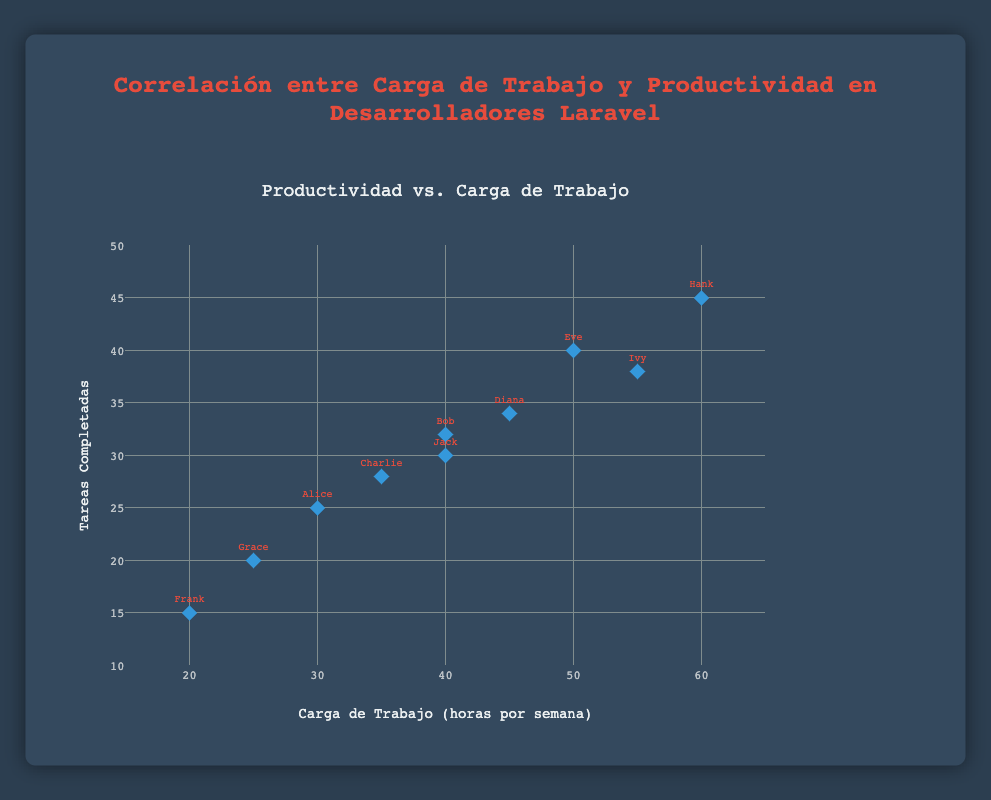How many developers are represented in the scatter plot? There are ten data points, each corresponding to a different developer. The plot visualizes each developer’s workload and productivity.
Answer: 10 Which developer completed the most tasks? By examining the y-axis and the data points, Hank has the highest y-value at 45 completed tasks.
Answer: Hank What is the workload and productivity of Alice? The scatter plot positions Alice's data point at 30 hours per week on the x-axis and 25 completed tasks on the y-axis.
Answer: 30 hours per week, 25 completed tasks Who works 40 hours per week, and how many tasks do they complete? The data points for Bob and Jack both align with 40 hours per week on the x-axis. Bob completes 32 tasks, and Jack completes 30 tasks.
Answer: Bob (32 tasks), Jack (30 tasks) Compare the productivity between Grace and Diana. Who is more productive, and by how much? Grace's productivity is at 20 tasks, while Diana's is at 34 tasks. The difference is 34 - 20 = 14.
Answer: Diana is more productive by 14 tasks What is the average number of tasks completed by developers working more than 40 hours per week? Developers working more than 40 hours are Diana (34 tasks), Eve (40 tasks), Ivy (38 tasks), and Hank (45 tasks). The average is calculated as (34 + 40 + 38 + 45)/4 = 157/4 = 39.25.
Answer: 39.25 tasks Is there a general correlation between workload and productivity based on the scatter plot? Observing the trend of data points, there seems to be a positive correlation: as workload hours increase, the number of tasks completed also increases.
Answer: Yes, positive correlation Which developers have an equal number of completed tasks but different workloads? By analyzing the y-values, Bob and Jack both completed 30 tasks, but Bob works 40 hours per week and Jack also works 40 hours per week, showing no distinct difference between their workloads.
Answer: None with different workloads (Only Bob and Jack with same) What is the median workload among all developers? The workloads are: 20, 25, 30, 35, 40, 40, 45, 50, 55, 60. Arranged in ascending order, the middle value between the 5th and 6th is (40+40)/2 = 40.
Answer: 40 hours per week Identify the range of completed tasks among all developers. The minimum and maximum y-values on the scatter plot represent the range of completed tasks. The minimum is Frank with 15 tasks, and the maximum is Hank with 45 tasks. The range is 45 - 15 = 30.
Answer: 30 tasks 